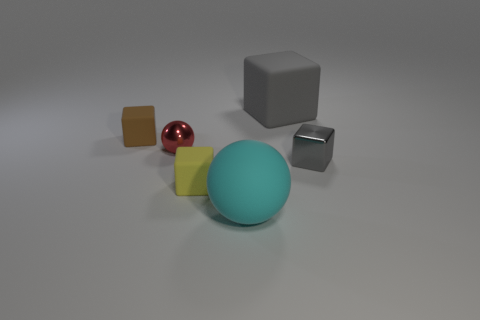Is there a gray rubber thing?
Provide a succinct answer. Yes. There is a small thing that is in front of the tiny shiny cube that is behind the big object that is in front of the small gray thing; what is its color?
Offer a very short reply. Yellow. There is a big rubber object that is behind the red thing; is there a large thing in front of it?
Your response must be concise. Yes. There is a tiny shiny object right of the big gray cube; is its color the same as the large object in front of the tiny yellow block?
Offer a terse response. No. How many gray cubes have the same size as the rubber sphere?
Provide a short and direct response. 1. There is a matte block in front of the brown thing; is it the same size as the cyan thing?
Provide a succinct answer. No. The red object is what shape?
Your answer should be very brief. Sphere. What size is the other cube that is the same color as the tiny metallic block?
Your answer should be very brief. Large. Does the gray thing behind the small gray metallic thing have the same material as the small red sphere?
Provide a succinct answer. No. Are there any objects of the same color as the metallic cube?
Offer a terse response. Yes. 